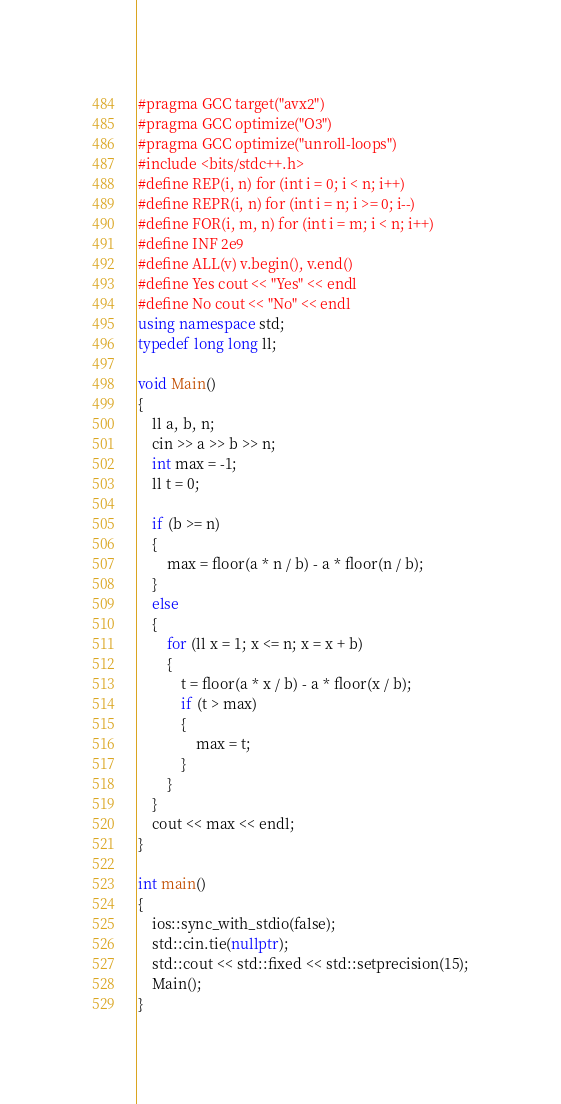<code> <loc_0><loc_0><loc_500><loc_500><_C++_>#pragma GCC target("avx2")
#pragma GCC optimize("O3")
#pragma GCC optimize("unroll-loops")
#include <bits/stdc++.h>
#define REP(i, n) for (int i = 0; i < n; i++)
#define REPR(i, n) for (int i = n; i >= 0; i--)
#define FOR(i, m, n) for (int i = m; i < n; i++)
#define INF 2e9
#define ALL(v) v.begin(), v.end()
#define Yes cout << "Yes" << endl
#define No cout << "No" << endl
using namespace std;
typedef long long ll;

void Main()
{
    ll a, b, n;
    cin >> a >> b >> n;
    int max = -1;
    ll t = 0;

    if (b >= n)
    {
        max = floor(a * n / b) - a * floor(n / b);
    }
    else
    {
        for (ll x = 1; x <= n; x = x + b)
        {
            t = floor(a * x / b) - a * floor(x / b);
            if (t > max)
            {
                max = t;
            }
        }
    }
    cout << max << endl;
}

int main()
{
    ios::sync_with_stdio(false);
    std::cin.tie(nullptr);
    std::cout << std::fixed << std::setprecision(15);
    Main();
}</code> 